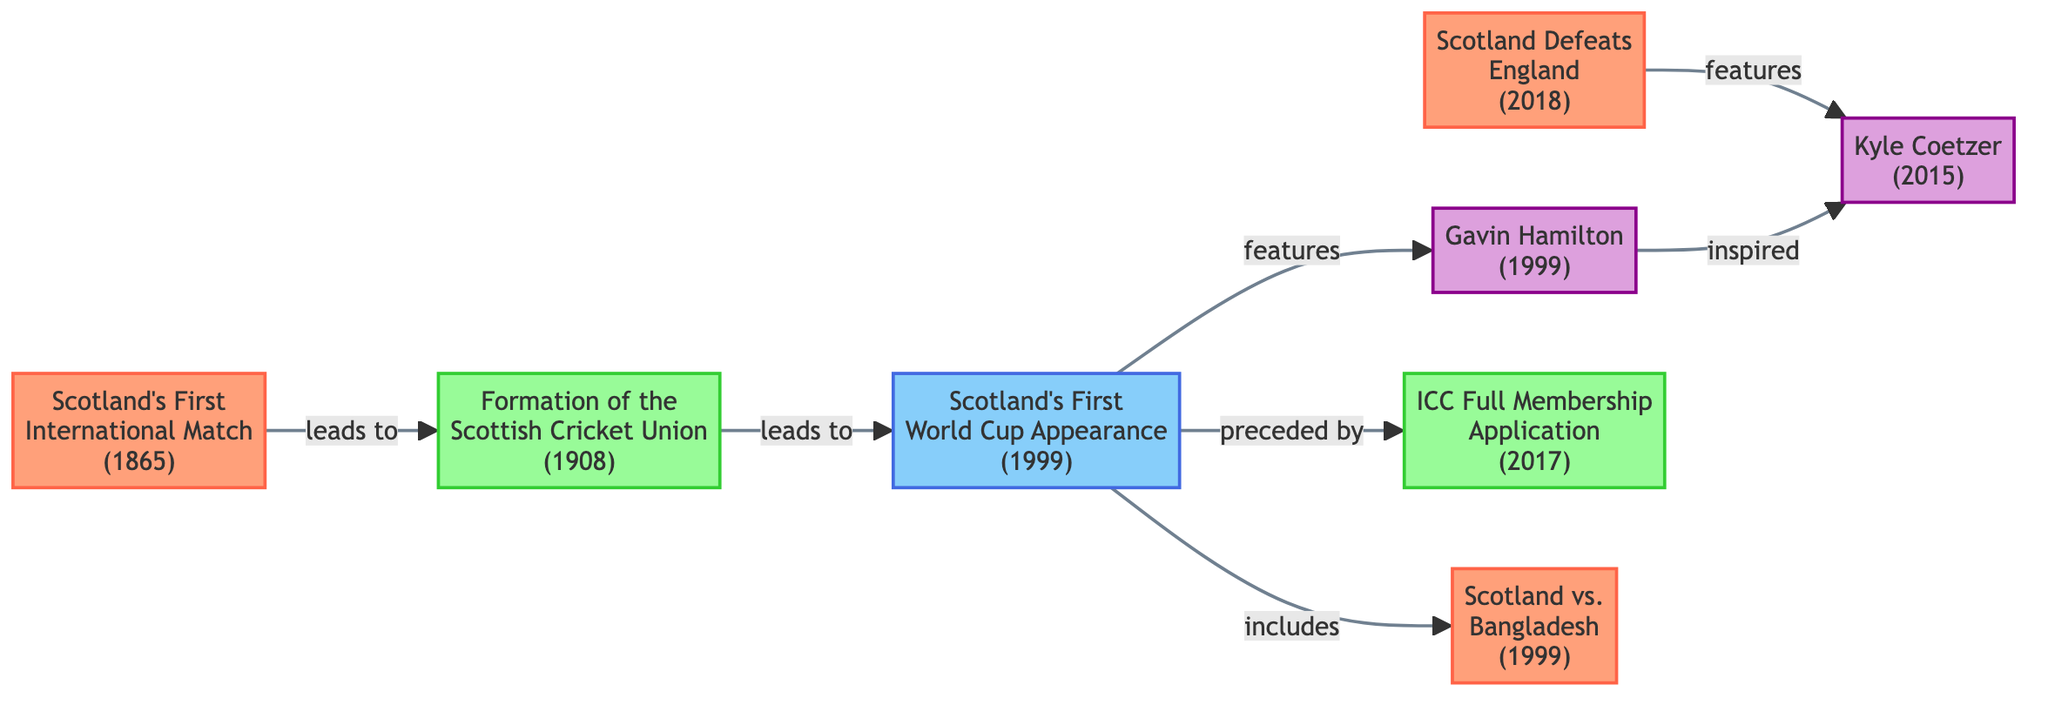What is the year of Scotland's first international match? The diagram indicates that Scotland's first international match occurred in the year 1865. This information is retrieved directly from the node labeled "Scotland's First International Match."
Answer: 1865 How many milestones are represented in the diagram? By examining the nodes, we can identify three milestones: "Formation of the Scottish Cricket Union," "ICC Full Membership Application," and the year regarding "Scotland's First World Cup Appearance." Thus, the total count of milestones is three.
Answer: 3 Which match features Gavin Hamilton? The node labeled "Scotland's First World Cup Appearance" connects to Gavin Hamilton through the "features" relationship. Thus, the match that features him is the "Scotland's First World Cup Appearance."
Answer: Scotland's First World Cup Appearance What event is preceded by Scotland's First World Cup Appearance? The "Scotland's First World Cup Appearance" node has a relationship indicating that it is "preceded by" the "ICC Full Membership Application," which is noted as occurring in 2017. Hence, the event that is preceded is the "ICC Full Membership Application."
Answer: ICC Full Membership Application Which player inspired Kyle Coetzer? The edge between Gavin Hamilton and Kyle Coetzer displays that Gavin Hamilton "inspired" Kyle Coetzer. As such, the answer is Gavin Hamilton.
Answer: Gavin Hamilton What event is Scotland's first World Cup appearance connected to regarding matches? The "Scotland's First World Cup Appearance" has a direct relationship indicating it "includes" the match against Bangladesh in 1999. Thus, the relevant event is "Scotland vs. Bangladesh."
Answer: Scotland vs. Bangladesh How many edges are there in the diagram connecting personalities to matches? The diagram shows two connections between personalities and matches: one from Gavin Hamilton to "Scotland's First World Cup Appearance" and another from Kyle Coetzer to "Scotland Defeats England." Therefore, there are two edges connecting personalities to matches.
Answer: 2 Which match marked a historic win against England? The node labeled "Scotland Defeats England" specifies a significant match that marks Scotland's historic win against England in ODI, making this the answer.
Answer: Scotland Defeats England 